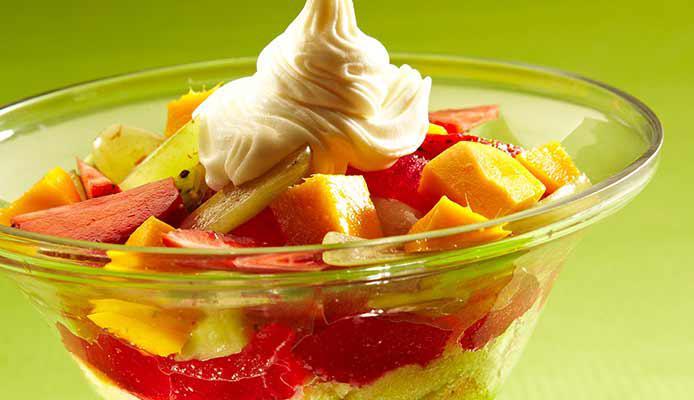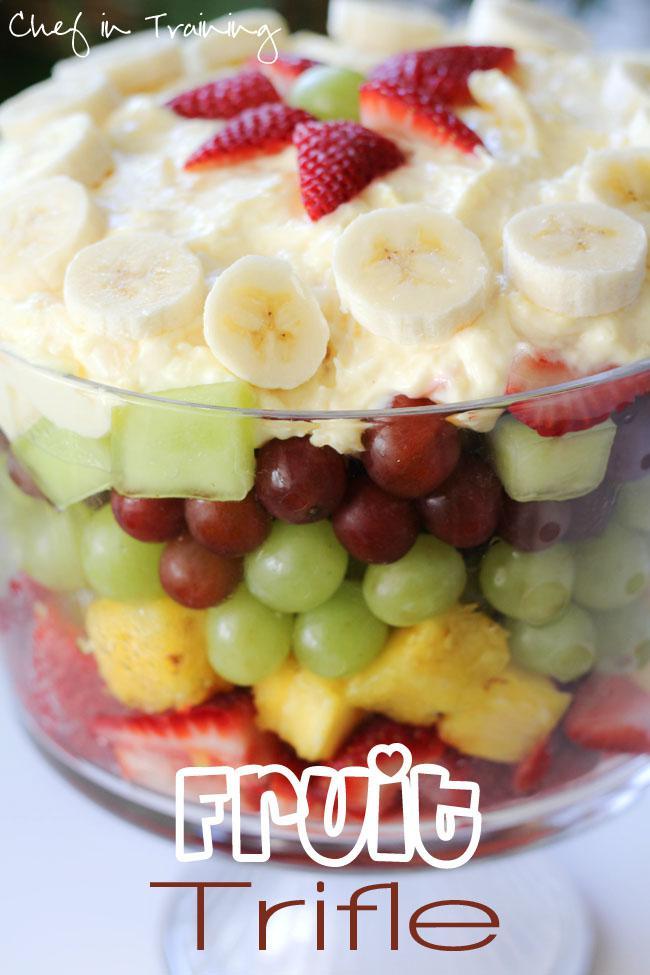The first image is the image on the left, the second image is the image on the right. Given the left and right images, does the statement "The image to the right is in a cup instead of a bowl." hold true? Answer yes or no. No. 